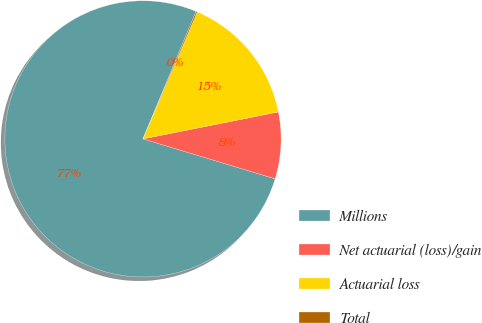Convert chart. <chart><loc_0><loc_0><loc_500><loc_500><pie_chart><fcel>Millions<fcel>Net actuarial (loss)/gain<fcel>Actuarial loss<fcel>Total<nl><fcel>76.61%<fcel>7.8%<fcel>15.44%<fcel>0.15%<nl></chart> 